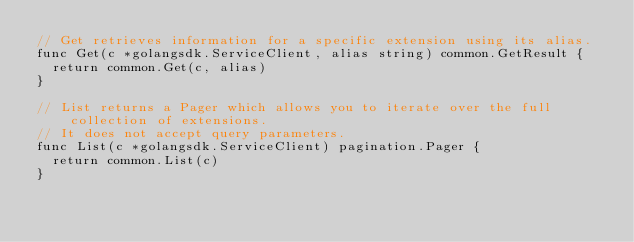<code> <loc_0><loc_0><loc_500><loc_500><_Go_>// Get retrieves information for a specific extension using its alias.
func Get(c *golangsdk.ServiceClient, alias string) common.GetResult {
	return common.Get(c, alias)
}

// List returns a Pager which allows you to iterate over the full collection of extensions.
// It does not accept query parameters.
func List(c *golangsdk.ServiceClient) pagination.Pager {
	return common.List(c)
}
</code> 